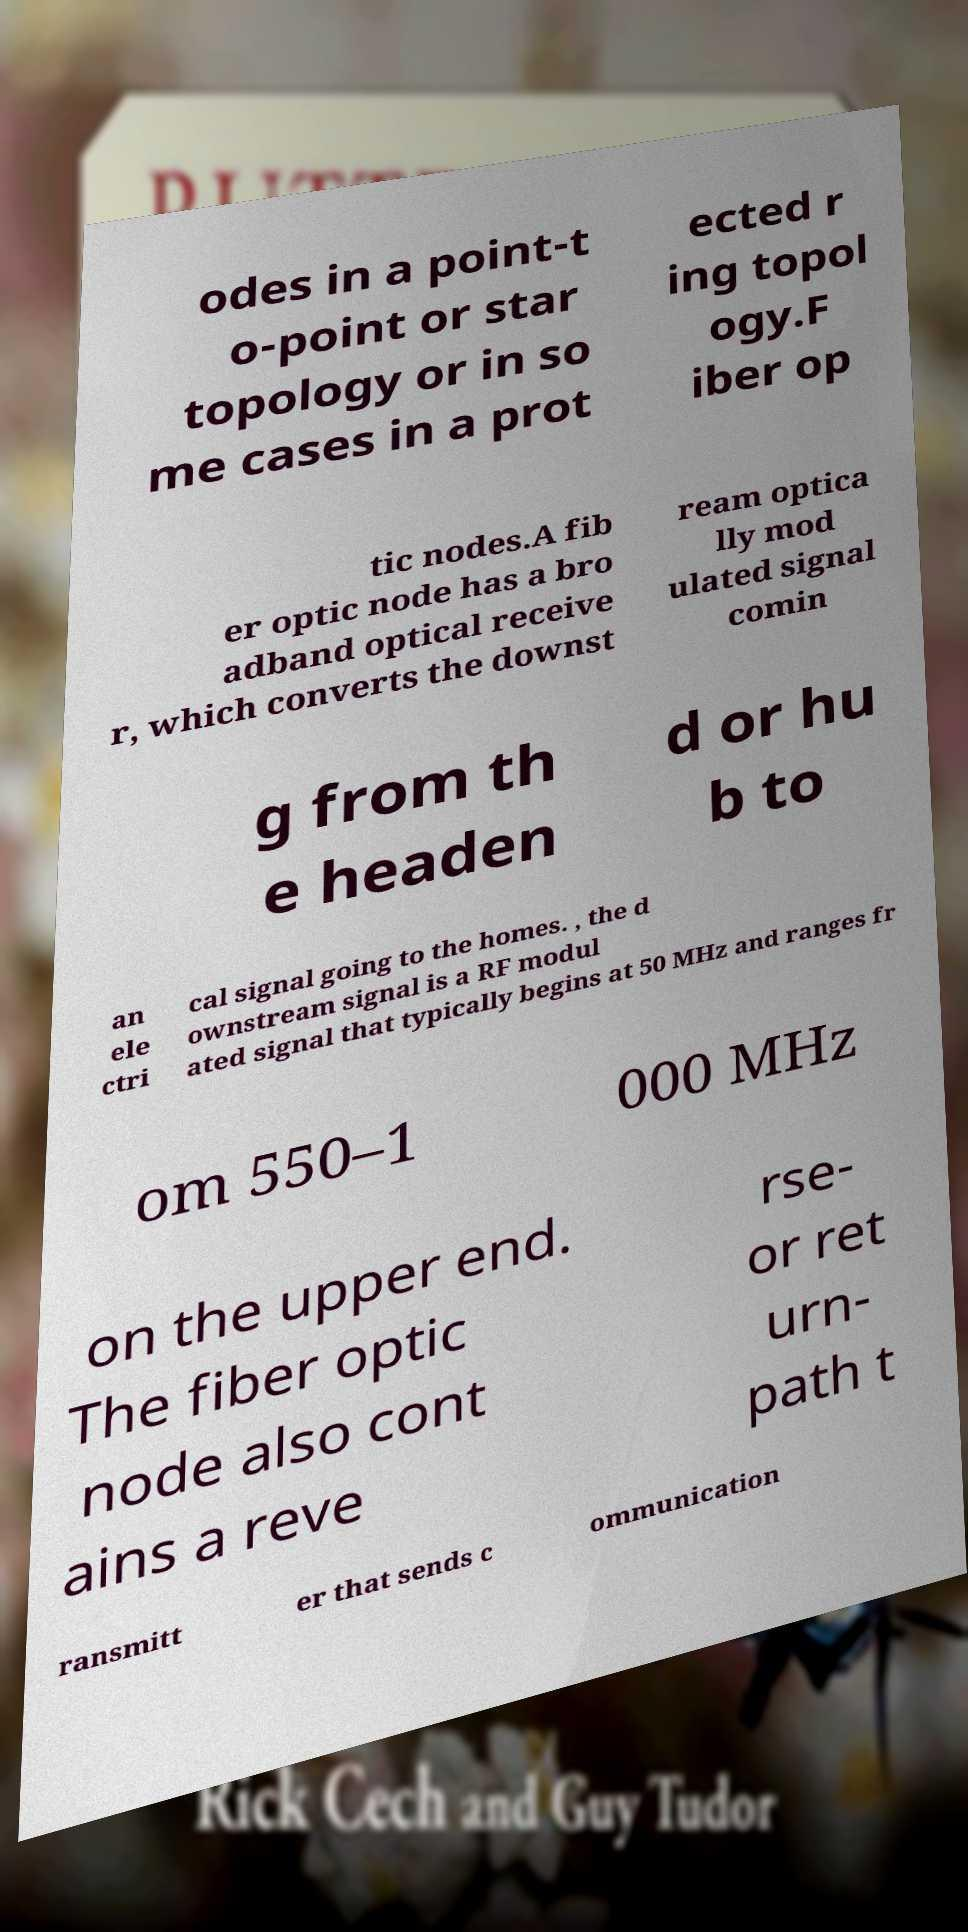Could you extract and type out the text from this image? odes in a point-t o-point or star topology or in so me cases in a prot ected r ing topol ogy.F iber op tic nodes.A fib er optic node has a bro adband optical receive r, which converts the downst ream optica lly mod ulated signal comin g from th e headen d or hu b to an ele ctri cal signal going to the homes. , the d ownstream signal is a RF modul ated signal that typically begins at 50 MHz and ranges fr om 550–1 000 MHz on the upper end. The fiber optic node also cont ains a reve rse- or ret urn- path t ransmitt er that sends c ommunication 